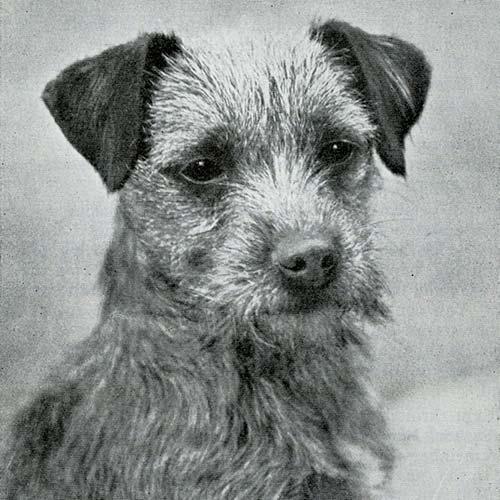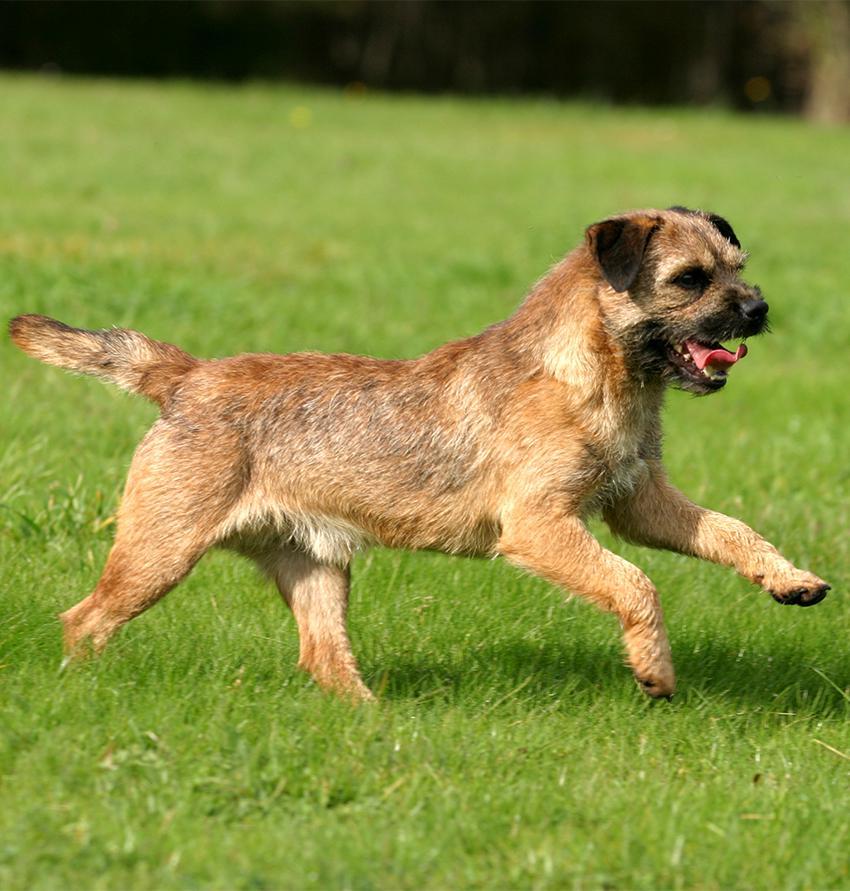The first image is the image on the left, the second image is the image on the right. Assess this claim about the two images: "The collar on the dog in the right image, it is clearly visible.". Correct or not? Answer yes or no. No. The first image is the image on the left, the second image is the image on the right. Examine the images to the left and right. Is the description "There are purple flowers behind the dog in one of the images but not the other." accurate? Answer yes or no. No. 